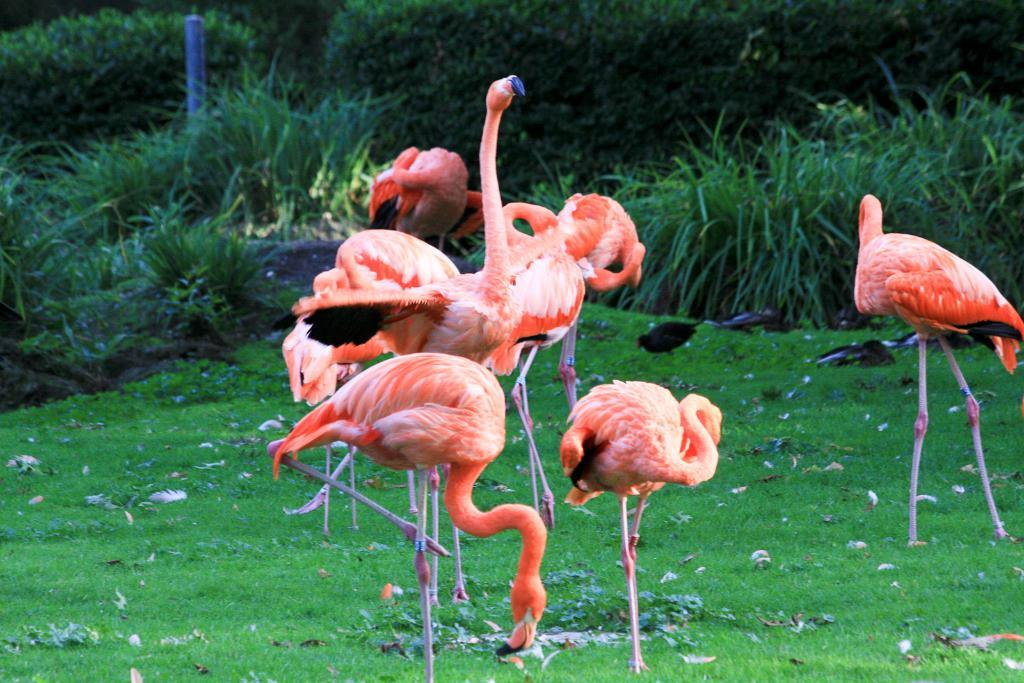What type of animals are present in the image? There are flamingos in the image. What is the flamingos standing on? The flamingos are standing on the grass. What can be seen in the background of the image? There is a bird, grass, and plants in the background of the image. What type of paper is being used for the activity in the image? There is no paper or activity present in the image; it features flamingos standing on the grass with a bird and plants in the background. 